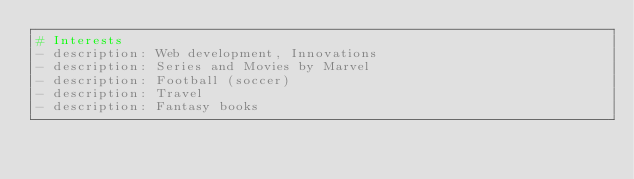Convert code to text. <code><loc_0><loc_0><loc_500><loc_500><_YAML_># Interests
- description: Web development, Innovations 
- description: Series and Movies by Marvel
- description: Football (soccer)
- description: Travel
- description: Fantasy books</code> 